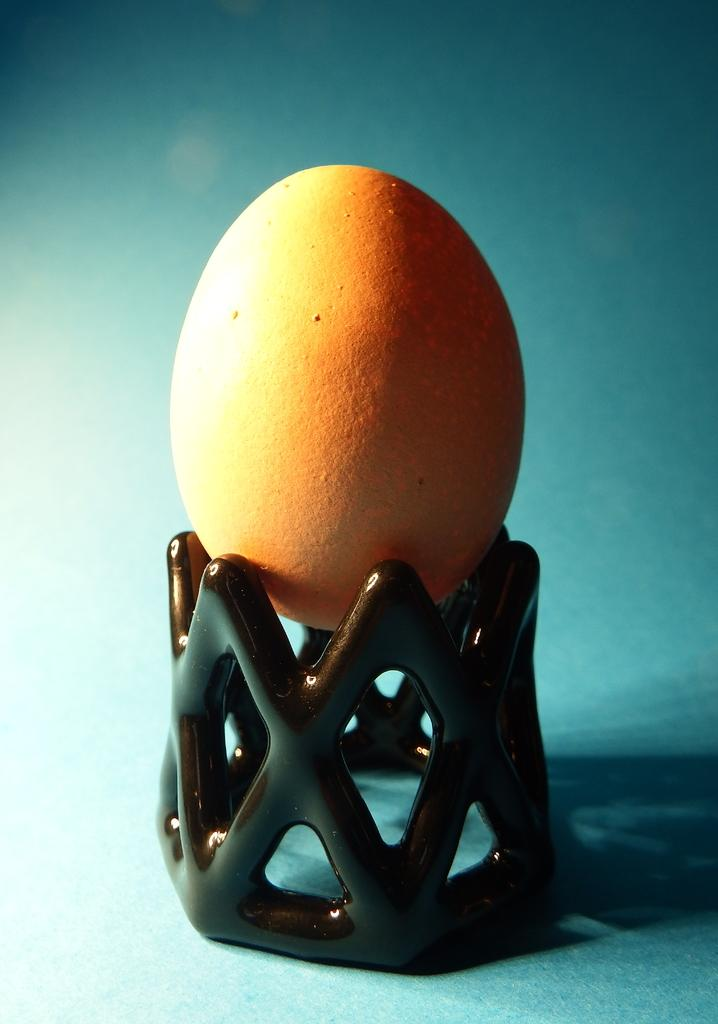What is the main subject of the image? The main subject of the image is an egg. Can you describe the position of the egg in the image? The egg is on an object. What type of shock can be seen affecting the egg in the image? There is no shock present in the image; it simply shows an egg on an object. Can you describe the bursting effect of the egg in the image? There is no bursting effect present in the image; the egg is intact. 